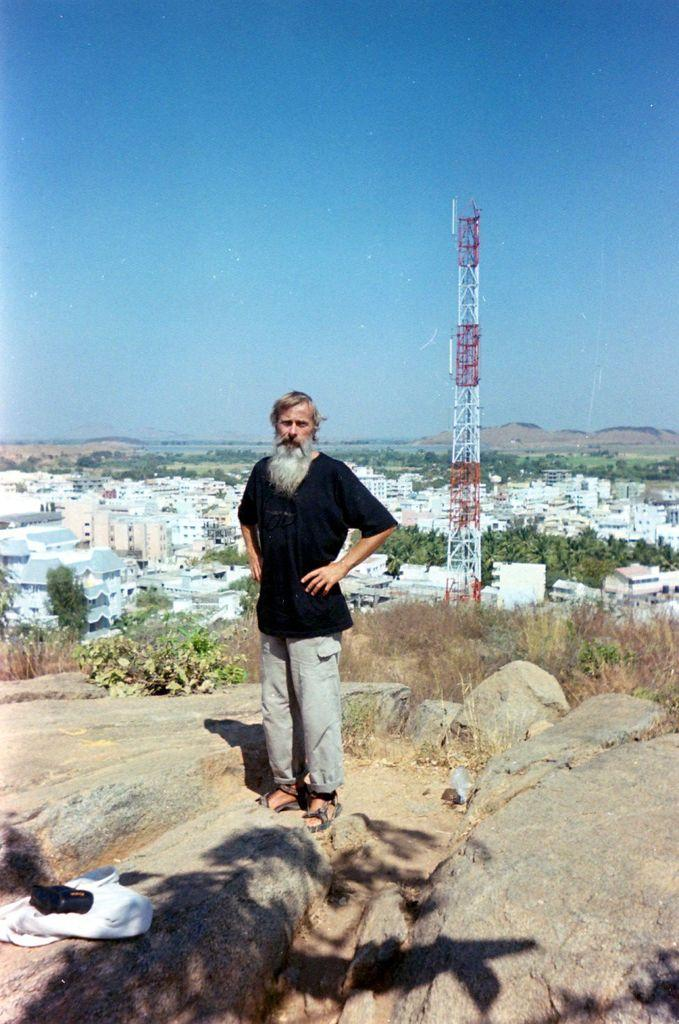What is the person in the image doing? The person is standing on the rocks. What can be seen behind the person? There are trees and houses behind the person. Is there any tall structure visible in the background? Yes, there is a tower visible in the background. What is the smell of the rocks in the image? The image does not provide any information about the smell of the rocks, as it is a visual medium. 